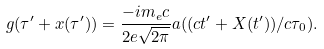Convert formula to latex. <formula><loc_0><loc_0><loc_500><loc_500>g ( \tau ^ { \prime } + x ( \tau ^ { \prime } ) ) = \frac { - i m _ { e } c } { 2 e \sqrt { 2 \pi } } a ( ( c t ^ { \prime } + X ( t ^ { \prime } ) ) / c \tau _ { 0 } ) .</formula> 